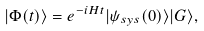Convert formula to latex. <formula><loc_0><loc_0><loc_500><loc_500>| \Phi ( t ) \rangle = e ^ { - i H t } | \psi _ { s y s } ( 0 ) \rangle | G \rangle ,</formula> 